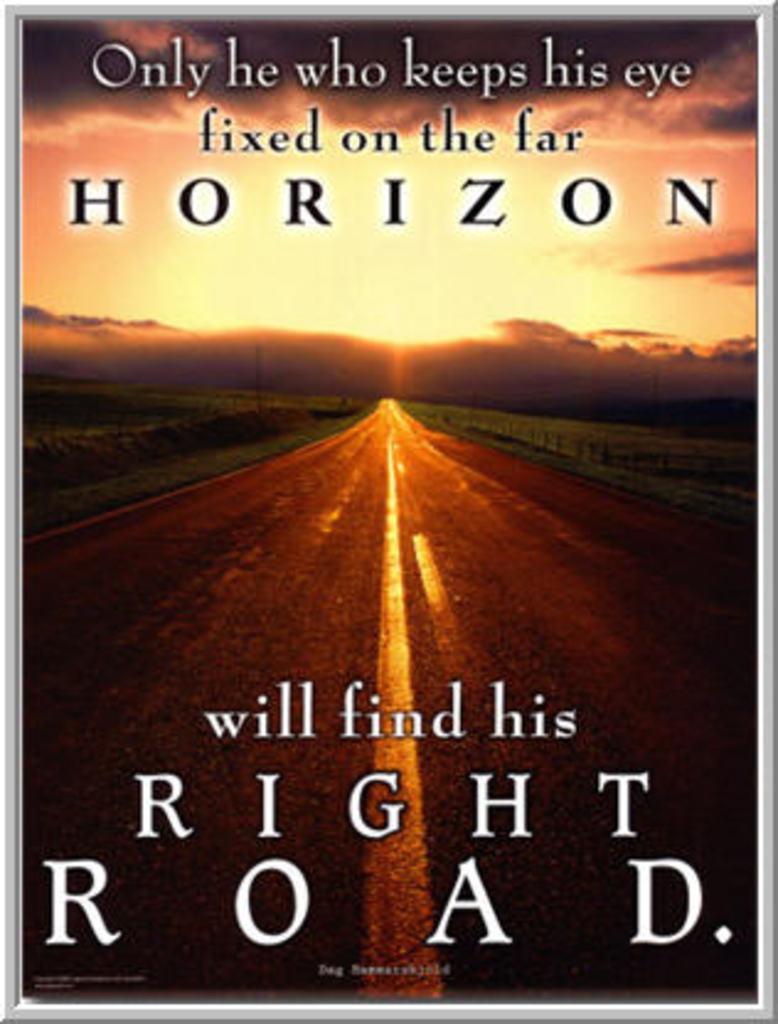What road will they find?
Provide a short and direct response. Right road. What is the name of the title?
Make the answer very short. Unanswerable. 